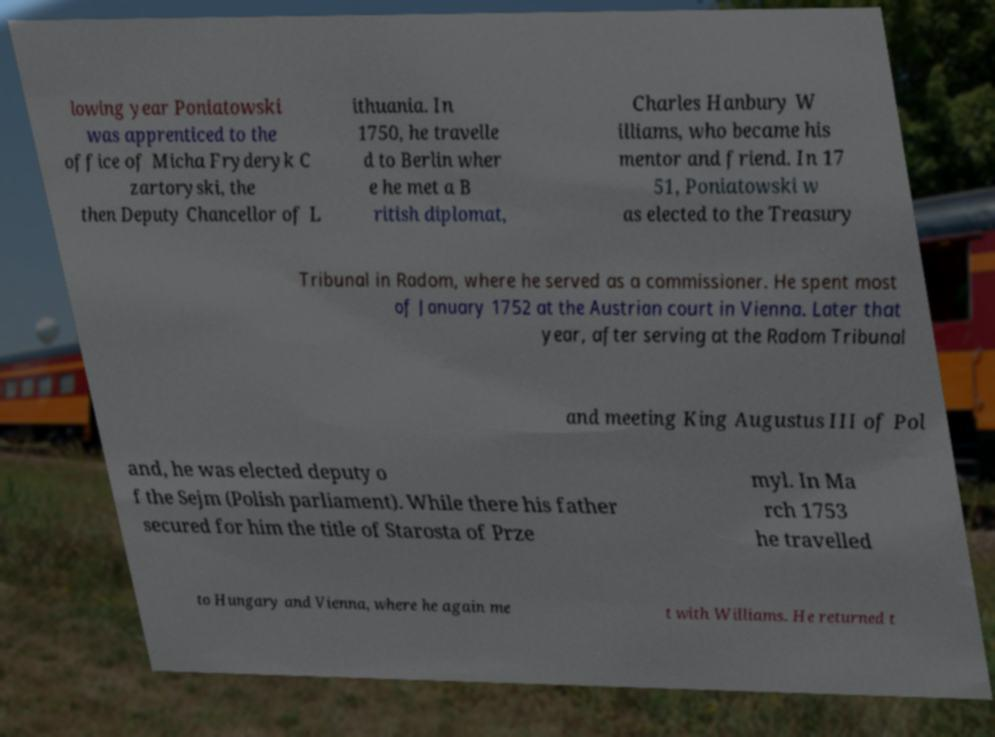Can you accurately transcribe the text from the provided image for me? lowing year Poniatowski was apprenticed to the office of Micha Fryderyk C zartoryski, the then Deputy Chancellor of L ithuania. In 1750, he travelle d to Berlin wher e he met a B ritish diplomat, Charles Hanbury W illiams, who became his mentor and friend. In 17 51, Poniatowski w as elected to the Treasury Tribunal in Radom, where he served as a commissioner. He spent most of January 1752 at the Austrian court in Vienna. Later that year, after serving at the Radom Tribunal and meeting King Augustus III of Pol and, he was elected deputy o f the Sejm (Polish parliament). While there his father secured for him the title of Starosta of Prze myl. In Ma rch 1753 he travelled to Hungary and Vienna, where he again me t with Williams. He returned t 